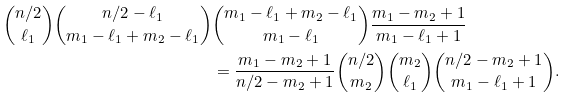Convert formula to latex. <formula><loc_0><loc_0><loc_500><loc_500>\binom { n / 2 } { \ell _ { 1 } } \binom { n / 2 - \ell _ { 1 } } { m _ { 1 } - \ell _ { 1 } + m _ { 2 } - \ell _ { 1 } } & \binom { m _ { 1 } - \ell _ { 1 } + m _ { 2 } - \ell _ { 1 } } { m _ { 1 } - \ell _ { 1 } } \frac { m _ { 1 } - m _ { 2 } + 1 } { m _ { 1 } - \ell _ { 1 } + 1 } \\ & = \frac { m _ { 1 } - m _ { 2 } + 1 } { n / 2 - m _ { 2 } + 1 } \binom { n / 2 } { m _ { 2 } } \binom { m _ { 2 } } { \ell _ { 1 } } \binom { n / 2 - m _ { 2 } + 1 } { m _ { 1 } - \ell _ { 1 } + 1 } .</formula> 